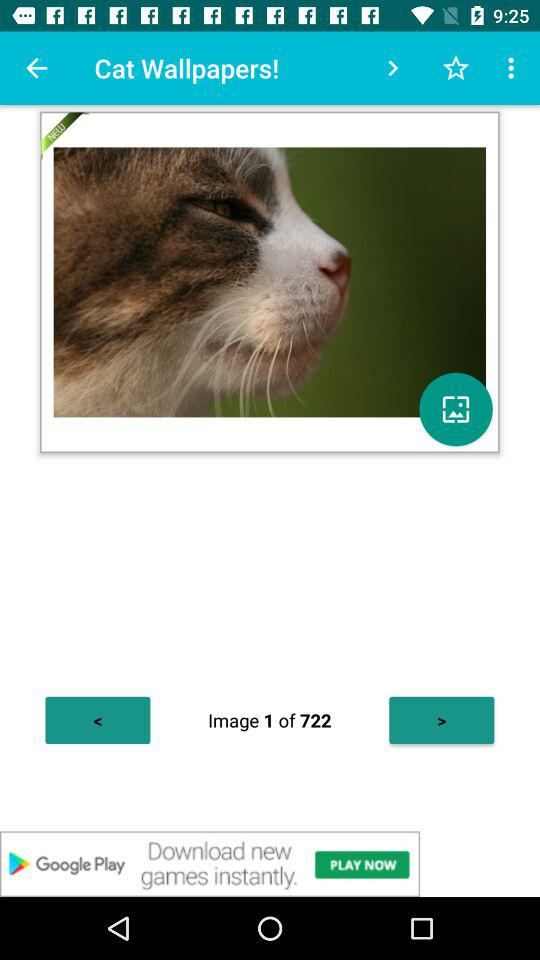What is the current image number? The current image number is 1. 